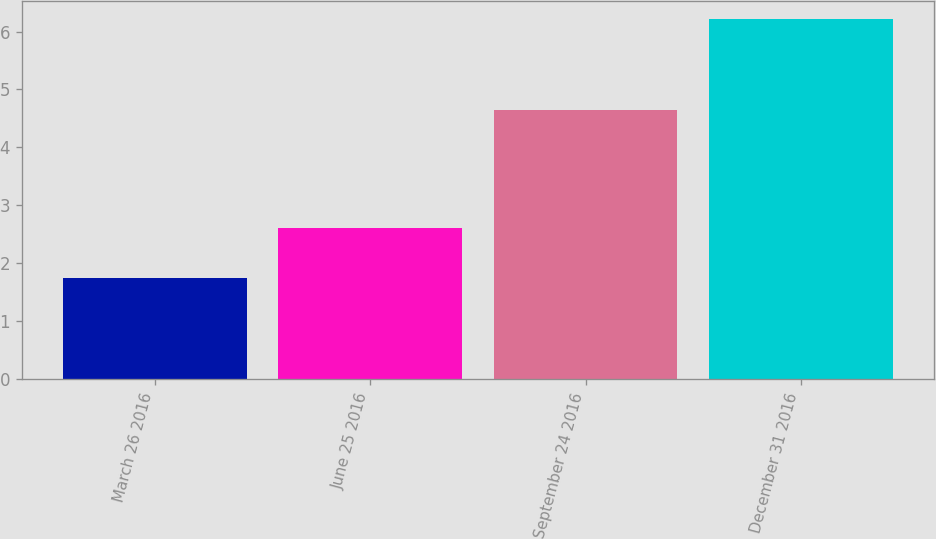Convert chart to OTSL. <chart><loc_0><loc_0><loc_500><loc_500><bar_chart><fcel>March 26 2016<fcel>June 25 2016<fcel>September 24 2016<fcel>December 31 2016<nl><fcel>1.75<fcel>2.6<fcel>4.65<fcel>6.22<nl></chart> 